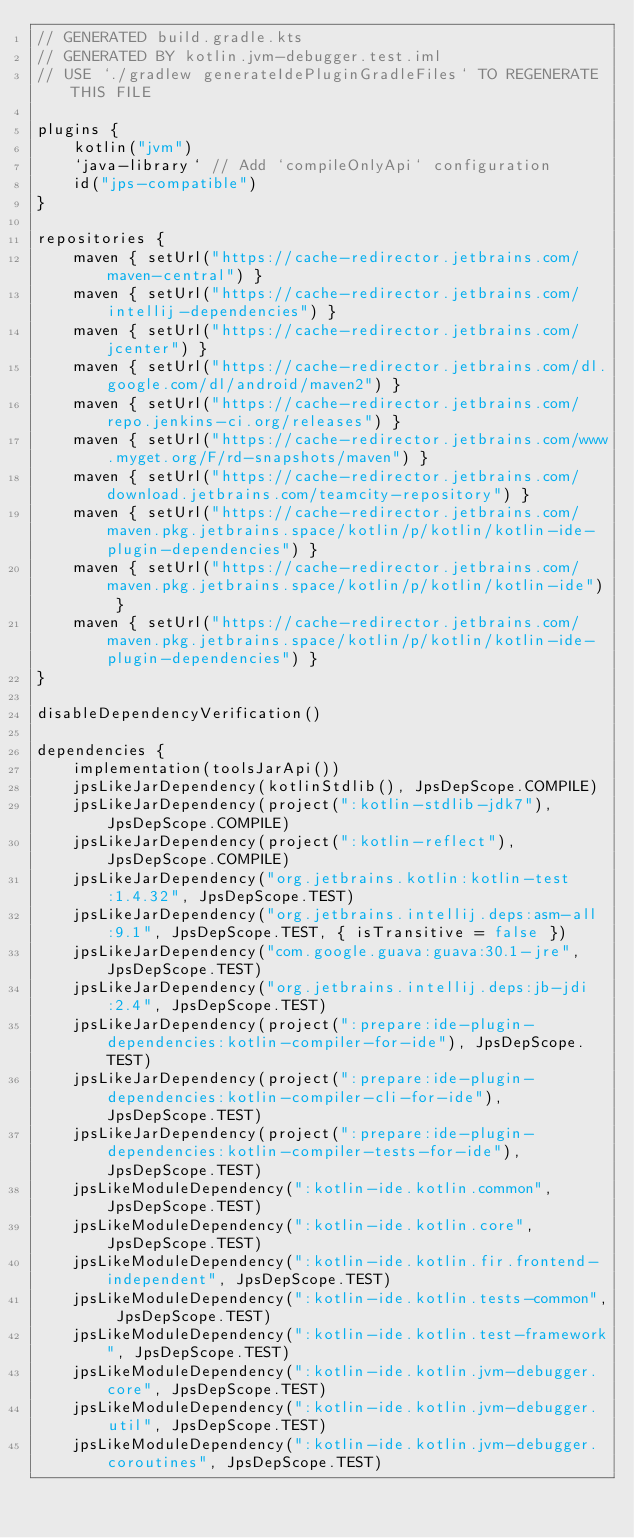<code> <loc_0><loc_0><loc_500><loc_500><_Kotlin_>// GENERATED build.gradle.kts
// GENERATED BY kotlin.jvm-debugger.test.iml
// USE `./gradlew generateIdePluginGradleFiles` TO REGENERATE THIS FILE

plugins {
    kotlin("jvm")
    `java-library` // Add `compileOnlyApi` configuration
    id("jps-compatible")
}

repositories {
    maven { setUrl("https://cache-redirector.jetbrains.com/maven-central") }
    maven { setUrl("https://cache-redirector.jetbrains.com/intellij-dependencies") }
    maven { setUrl("https://cache-redirector.jetbrains.com/jcenter") }
    maven { setUrl("https://cache-redirector.jetbrains.com/dl.google.com/dl/android/maven2") }
    maven { setUrl("https://cache-redirector.jetbrains.com/repo.jenkins-ci.org/releases") }
    maven { setUrl("https://cache-redirector.jetbrains.com/www.myget.org/F/rd-snapshots/maven") }
    maven { setUrl("https://cache-redirector.jetbrains.com/download.jetbrains.com/teamcity-repository") }
    maven { setUrl("https://cache-redirector.jetbrains.com/maven.pkg.jetbrains.space/kotlin/p/kotlin/kotlin-ide-plugin-dependencies") }
    maven { setUrl("https://cache-redirector.jetbrains.com/maven.pkg.jetbrains.space/kotlin/p/kotlin/kotlin-ide") }
    maven { setUrl("https://cache-redirector.jetbrains.com/maven.pkg.jetbrains.space/kotlin/p/kotlin/kotlin-ide-plugin-dependencies") }
}

disableDependencyVerification()

dependencies {
    implementation(toolsJarApi())
    jpsLikeJarDependency(kotlinStdlib(), JpsDepScope.COMPILE)
    jpsLikeJarDependency(project(":kotlin-stdlib-jdk7"), JpsDepScope.COMPILE)
    jpsLikeJarDependency(project(":kotlin-reflect"), JpsDepScope.COMPILE)
    jpsLikeJarDependency("org.jetbrains.kotlin:kotlin-test:1.4.32", JpsDepScope.TEST)
    jpsLikeJarDependency("org.jetbrains.intellij.deps:asm-all:9.1", JpsDepScope.TEST, { isTransitive = false })
    jpsLikeJarDependency("com.google.guava:guava:30.1-jre", JpsDepScope.TEST)
    jpsLikeJarDependency("org.jetbrains.intellij.deps:jb-jdi:2.4", JpsDepScope.TEST)
    jpsLikeJarDependency(project(":prepare:ide-plugin-dependencies:kotlin-compiler-for-ide"), JpsDepScope.TEST)
    jpsLikeJarDependency(project(":prepare:ide-plugin-dependencies:kotlin-compiler-cli-for-ide"), JpsDepScope.TEST)
    jpsLikeJarDependency(project(":prepare:ide-plugin-dependencies:kotlin-compiler-tests-for-ide"), JpsDepScope.TEST)
    jpsLikeModuleDependency(":kotlin-ide.kotlin.common", JpsDepScope.TEST)
    jpsLikeModuleDependency(":kotlin-ide.kotlin.core", JpsDepScope.TEST)
    jpsLikeModuleDependency(":kotlin-ide.kotlin.fir.frontend-independent", JpsDepScope.TEST)
    jpsLikeModuleDependency(":kotlin-ide.kotlin.tests-common", JpsDepScope.TEST)
    jpsLikeModuleDependency(":kotlin-ide.kotlin.test-framework", JpsDepScope.TEST)
    jpsLikeModuleDependency(":kotlin-ide.kotlin.jvm-debugger.core", JpsDepScope.TEST)
    jpsLikeModuleDependency(":kotlin-ide.kotlin.jvm-debugger.util", JpsDepScope.TEST)
    jpsLikeModuleDependency(":kotlin-ide.kotlin.jvm-debugger.coroutines", JpsDepScope.TEST)</code> 